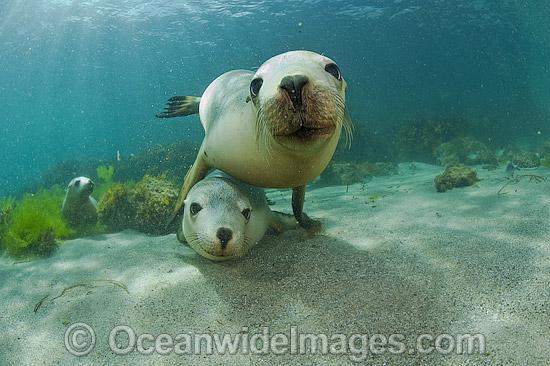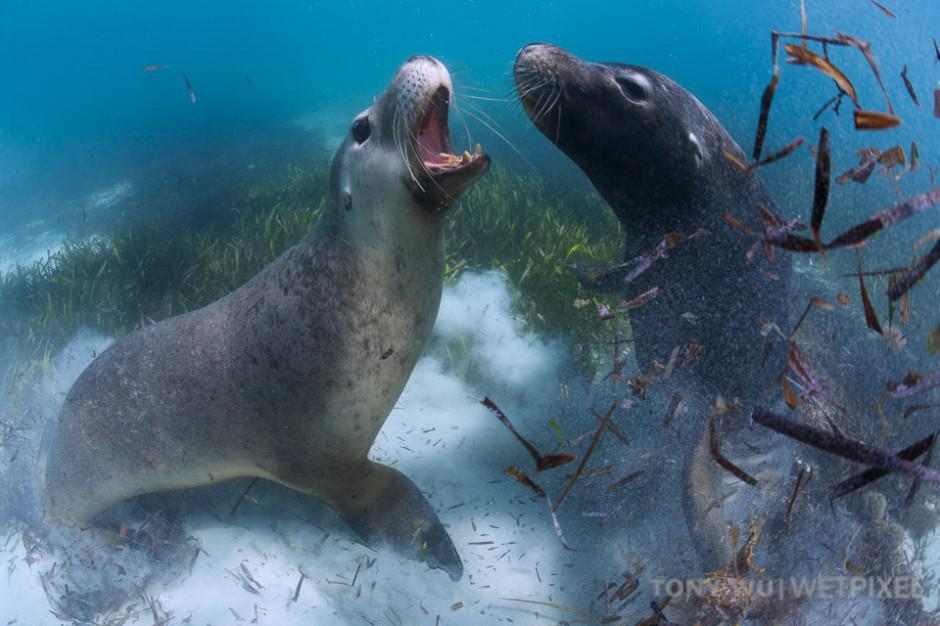The first image is the image on the left, the second image is the image on the right. For the images shown, is this caption "In the left image there is one seal on top of another seal." true? Answer yes or no. Yes. The first image is the image on the left, the second image is the image on the right. Evaluate the accuracy of this statement regarding the images: "None of the images have more than two seals.". Is it true? Answer yes or no. No. 